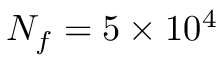Convert formula to latex. <formula><loc_0><loc_0><loc_500><loc_500>N _ { f } = 5 \times 1 0 ^ { 4 }</formula> 